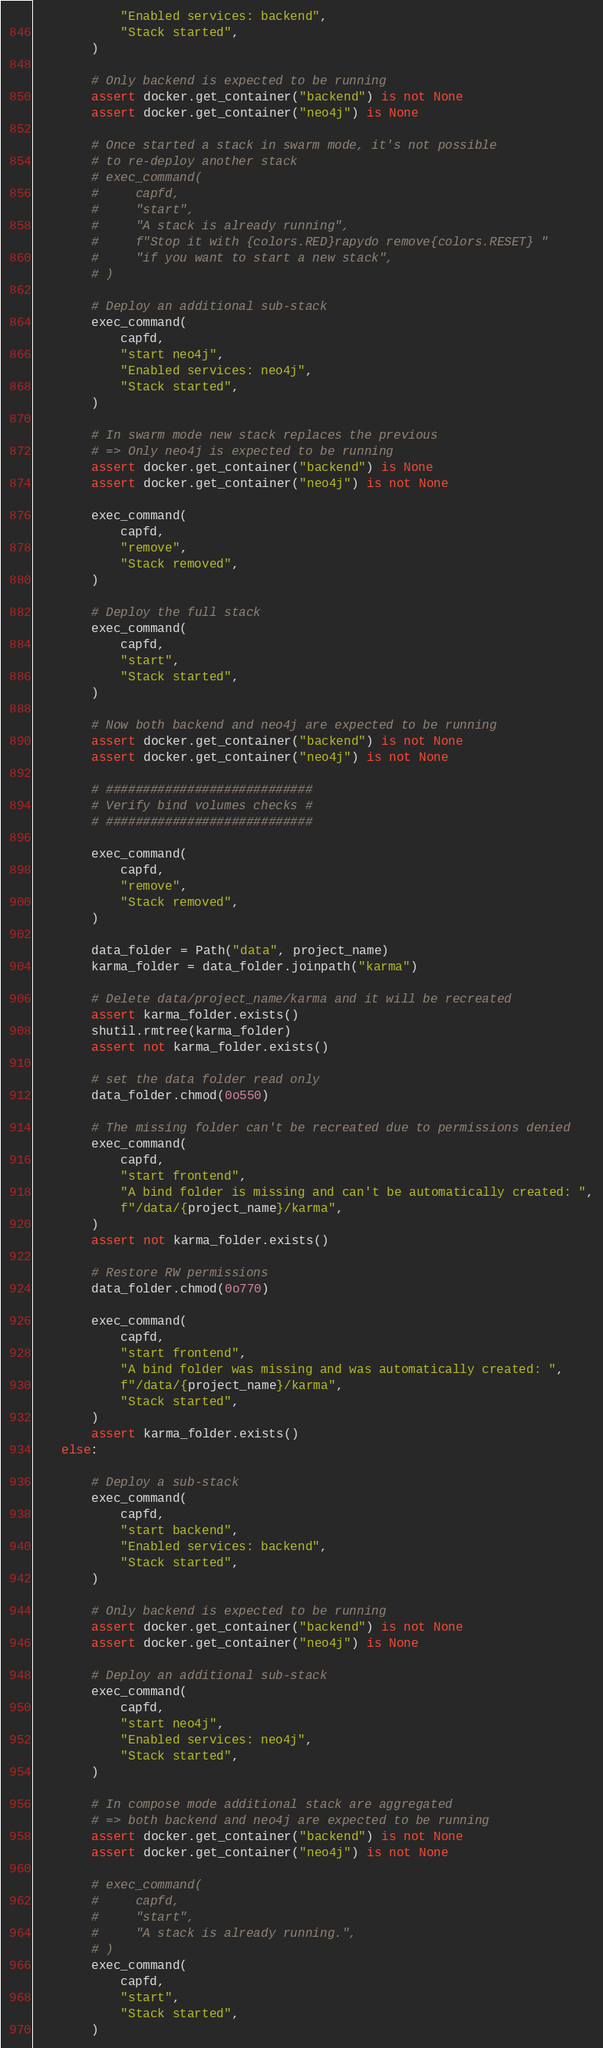<code> <loc_0><loc_0><loc_500><loc_500><_Python_>            "Enabled services: backend",
            "Stack started",
        )

        # Only backend is expected to be running
        assert docker.get_container("backend") is not None
        assert docker.get_container("neo4j") is None

        # Once started a stack in swarm mode, it's not possible
        # to re-deploy another stack
        # exec_command(
        #     capfd,
        #     "start",
        #     "A stack is already running",
        #     f"Stop it with {colors.RED}rapydo remove{colors.RESET} "
        #     "if you want to start a new stack",
        # )

        # Deploy an additional sub-stack
        exec_command(
            capfd,
            "start neo4j",
            "Enabled services: neo4j",
            "Stack started",
        )

        # In swarm mode new stack replaces the previous
        # => Only neo4j is expected to be running
        assert docker.get_container("backend") is None
        assert docker.get_container("neo4j") is not None

        exec_command(
            capfd,
            "remove",
            "Stack removed",
        )

        # Deploy the full stack
        exec_command(
            capfd,
            "start",
            "Stack started",
        )

        # Now both backend and neo4j are expected to be running
        assert docker.get_container("backend") is not None
        assert docker.get_container("neo4j") is not None

        # ############################
        # Verify bind volumes checks #
        # ############################

        exec_command(
            capfd,
            "remove",
            "Stack removed",
        )

        data_folder = Path("data", project_name)
        karma_folder = data_folder.joinpath("karma")

        # Delete data/project_name/karma and it will be recreated
        assert karma_folder.exists()
        shutil.rmtree(karma_folder)
        assert not karma_folder.exists()

        # set the data folder read only
        data_folder.chmod(0o550)

        # The missing folder can't be recreated due to permissions denied
        exec_command(
            capfd,
            "start frontend",
            "A bind folder is missing and can't be automatically created: ",
            f"/data/{project_name}/karma",
        )
        assert not karma_folder.exists()

        # Restore RW permissions
        data_folder.chmod(0o770)

        exec_command(
            capfd,
            "start frontend",
            "A bind folder was missing and was automatically created: ",
            f"/data/{project_name}/karma",
            "Stack started",
        )
        assert karma_folder.exists()
    else:

        # Deploy a sub-stack
        exec_command(
            capfd,
            "start backend",
            "Enabled services: backend",
            "Stack started",
        )

        # Only backend is expected to be running
        assert docker.get_container("backend") is not None
        assert docker.get_container("neo4j") is None

        # Deploy an additional sub-stack
        exec_command(
            capfd,
            "start neo4j",
            "Enabled services: neo4j",
            "Stack started",
        )

        # In compose mode additional stack are aggregated
        # => both backend and neo4j are expected to be running
        assert docker.get_container("backend") is not None
        assert docker.get_container("neo4j") is not None

        # exec_command(
        #     capfd,
        #     "start",
        #     "A stack is already running.",
        # )
        exec_command(
            capfd,
            "start",
            "Stack started",
        )
</code> 